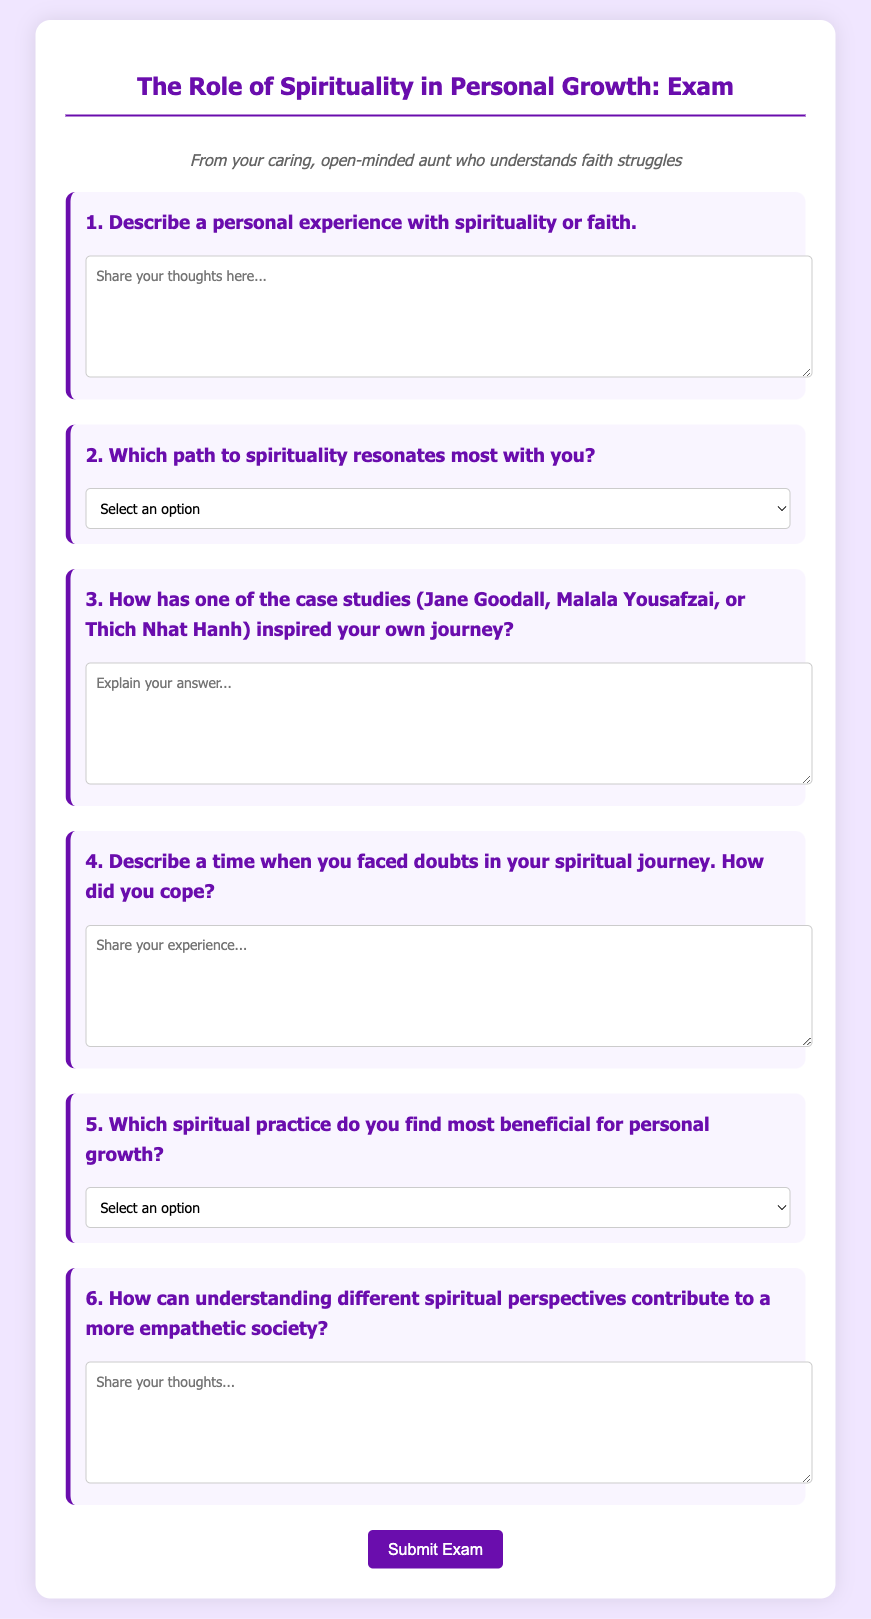What is the title of the exam? The title of the exam is presented at the top of the document, which indicates the subject of the exam.
Answer: The Role of Spirituality in Personal Growth: Exam How many questions are in the exam? The document lists a series of six questions that participants need to answer.
Answer: 6 What is the first question about? The first question asks participants to describe a personal experience with spirituality or faith.
Answer: Describe a personal experience with spirituality or faith Which spiritual practice is listed as an option for personal growth? The document includes various options for spiritual practices, one of which is meditation and mindfulness.
Answer: Meditation and Mindfulness Who are the case studies mentioned in the exam? The exam references three motivating figures whose journeys inspire personal growth—Jane Goodall, Malala Yousafzai, and Thich Nhat Hanh.
Answer: Jane Goodall, Malala Yousafzai, Thich Nhat Hanh What color is the background of the exam container? The exam container's background color is indicated in the styling section of the document, which informs the visual design.
Answer: White 